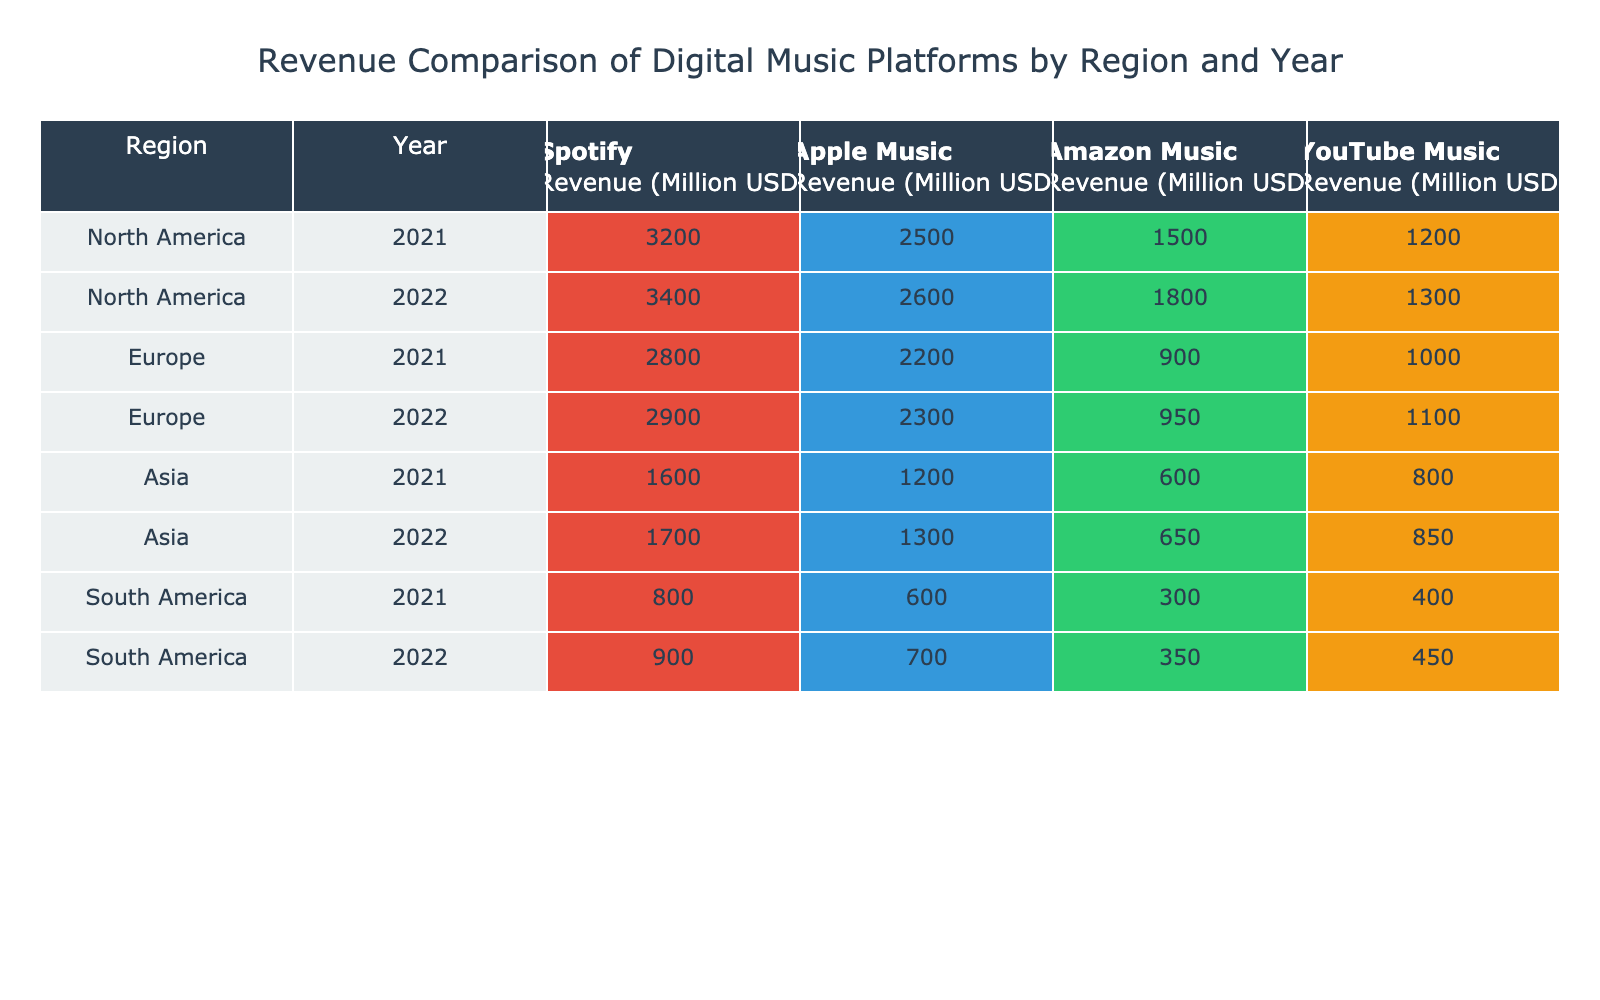What was the revenue of Spotify in North America in 2022? The table shows that in 2022, the revenue for Spotify in North America is listed as 3400 million USD.
Answer: 3400 million USD Which platform had the highest revenue in Europe for the year 2021? By looking at the table, we can see that in 2021, Spotify had a revenue of 2800 million USD, Apple Music had 2200 million USD, Amazon Music had 900 million USD, and YouTube Music had 1000 million USD. Therefore, the highest revenue is from Spotify with 2800 million USD.
Answer: Spotify What is the total revenue for Amazon Music across all regions in 2022? To find total revenue for Amazon Music in 2022, we refer to the values for each region: North America (1800 million USD), Europe (950 million USD), Asia (650 million USD), and South America (350 million USD). Adding these gives: 1800 + 950 + 650 + 350 = 3750 million USD.
Answer: 3750 million USD Did YouTube Music generate more revenue than Apple Music in Asia in 2021? In 2021, YouTube Music's revenue in Asia was 800 million USD, while Apple Music's revenue was 1200 million USD. Since 800 is less than 1200, the answer is no.
Answer: No What was the difference in revenue between Spotify and Apple Music in South America for the year 2022? In South America in 2022, Spotify revenue is 900 million USD, and Apple Music revenue is 700 million USD. The difference is calculated by subtracting Apple Music's revenue from Spotify's: 900 - 700 = 200 million USD.
Answer: 200 million USD Which region had the least total revenue for YouTube Music in 2021 and what was it? To find the least total revenue for YouTube Music in 2021, we look at the revenues: North America (1200 million USD), Europe (1000 million USD), Asia (800 million USD), and South America (400 million USD). The lowest revenue is in South America with 400 million USD.
Answer: South America, 400 million USD Which platform had the lowest revenue in Asia for 2022? In Asia for 2022, the revenue values are: Spotify (1700 million USD), Apple Music (1300 million USD), Amazon Music (650 million USD), and YouTube Music (850 million USD). The lowest among these is Amazon Music at 650 million USD.
Answer: Amazon Music What is the average revenue of Apple Music across all regions for the years presented? We look at the Apple Music revenues: 2500 (2021, NA), 2600 (2022, NA), 2200 (2021, Europe), 2300 (2022, Europe), 1200 (2021, Asia), 1300 (2022, Asia), 600 (2021, SA), 700 (2022, SA). Adding these gives 2500 + 2600 + 2200 + 2300 + 1200 + 1300 + 600 + 700 = 13600 million USD. There are 8 data points, so the average is 13600 / 8 = 1700 million USD.
Answer: 1700 million USD What was the total revenue for Spotify in North America for the years included? For North America in the years provided, the Spotify revenues are 3200 million USD for 2021 and 3400 million USD for 2022. Adding these gives: 3200 + 3400 = 6600 million USD.
Answer: 6600 million USD 